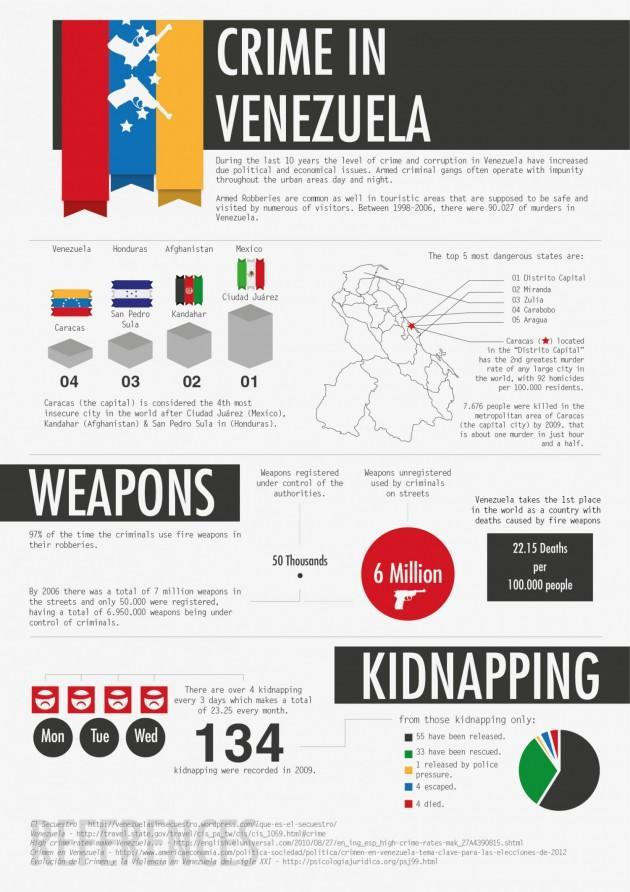How many people died out of the 134 kidnappings in Venezuela in 2009?
Answer the question with a short phrase. 4 How many kidnapping were reported in Venezuela in 2009? 134 What is the number of unregistered weapons used by criminals on Venezuela streets? 6 Million What is the number of weapons registered under control of the authorities in Venezuela? 50 Thousands Which is considered as the second most dangerous city in the world? Kandahar (Afghanistan) What is the capital of Venezuela? Caracas 